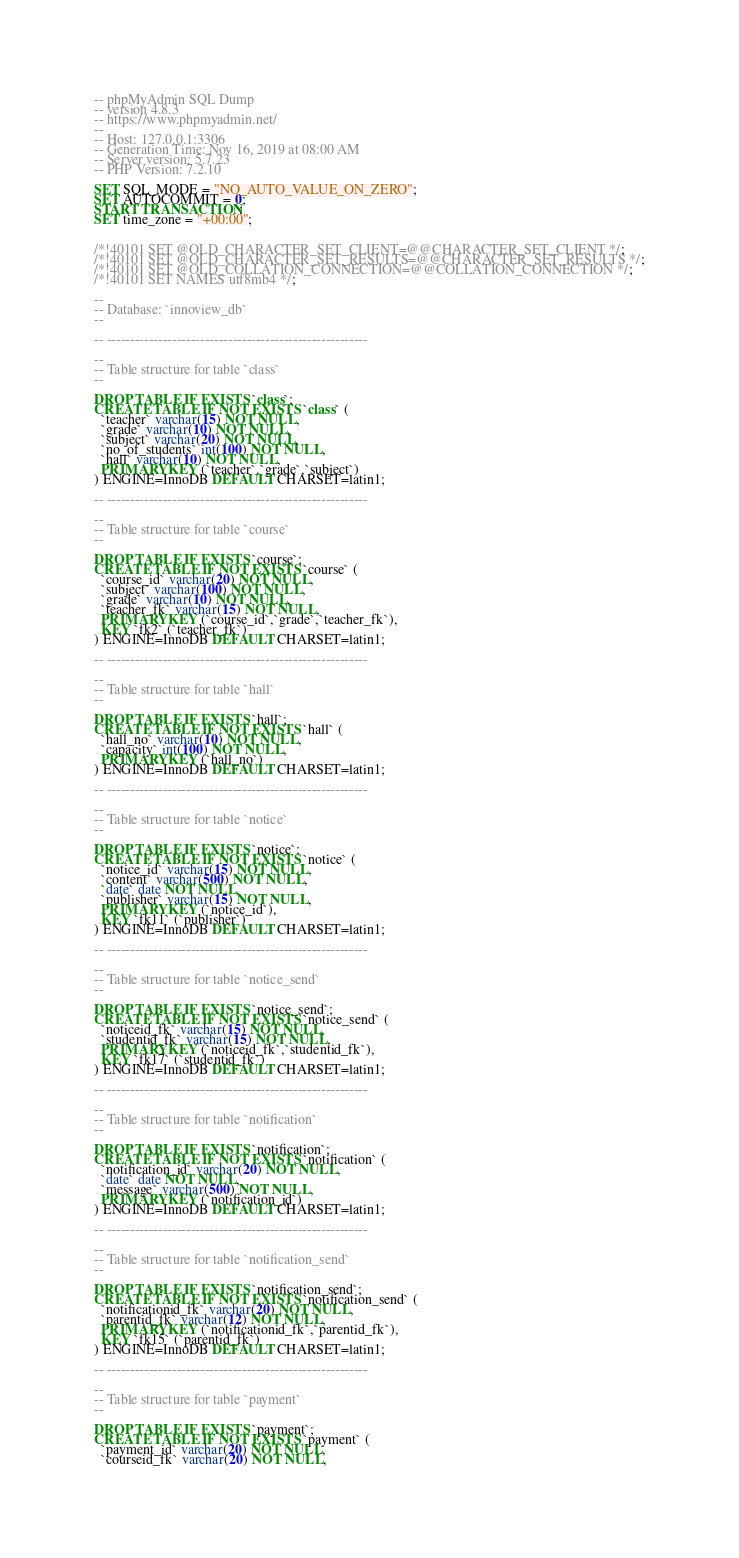<code> <loc_0><loc_0><loc_500><loc_500><_SQL_>-- phpMyAdmin SQL Dump
-- version 4.8.3
-- https://www.phpmyadmin.net/
--
-- Host: 127.0.0.1:3306
-- Generation Time: Nov 16, 2019 at 08:00 AM
-- Server version: 5.7.23
-- PHP Version: 7.2.10

SET SQL_MODE = "NO_AUTO_VALUE_ON_ZERO";
SET AUTOCOMMIT = 0;
START TRANSACTION;
SET time_zone = "+00:00";


/*!40101 SET @OLD_CHARACTER_SET_CLIENT=@@CHARACTER_SET_CLIENT */;
/*!40101 SET @OLD_CHARACTER_SET_RESULTS=@@CHARACTER_SET_RESULTS */;
/*!40101 SET @OLD_COLLATION_CONNECTION=@@COLLATION_CONNECTION */;
/*!40101 SET NAMES utf8mb4 */;

--
-- Database: `innoview_db`
--

-- --------------------------------------------------------

--
-- Table structure for table `class`
--

DROP TABLE IF EXISTS `class`;
CREATE TABLE IF NOT EXISTS `class` (
  `teacher` varchar(15) NOT NULL,
  `grade` varchar(10) NOT NULL,
  `subject` varchar(20) NOT NULL,
  `no_of_students` int(100) NOT NULL,
  `hall` varchar(10) NOT NULL,
  PRIMARY KEY (`teacher`,`grade`,`subject`)
) ENGINE=InnoDB DEFAULT CHARSET=latin1;

-- --------------------------------------------------------

--
-- Table structure for table `course`
--

DROP TABLE IF EXISTS `course`;
CREATE TABLE IF NOT EXISTS `course` (
  `course_id` varchar(20) NOT NULL,
  `subject` varchar(100) NOT NULL,
  `grade` varchar(10) NOT NULL,
  `teacher_fk` varchar(15) NOT NULL,
  PRIMARY KEY (`course_id`,`grade`,`teacher_fk`),
  KEY `fk2` (`teacher_fk`)
) ENGINE=InnoDB DEFAULT CHARSET=latin1;

-- --------------------------------------------------------

--
-- Table structure for table `hall`
--

DROP TABLE IF EXISTS `hall`;
CREATE TABLE IF NOT EXISTS `hall` (
  `hall_no` varchar(10) NOT NULL,
  `capacity` int(100) NOT NULL,
  PRIMARY KEY (`hall_no`)
) ENGINE=InnoDB DEFAULT CHARSET=latin1;

-- --------------------------------------------------------

--
-- Table structure for table `notice`
--

DROP TABLE IF EXISTS `notice`;
CREATE TABLE IF NOT EXISTS `notice` (
  `notice_id` varchar(15) NOT NULL,
  `content` varchar(500) NOT NULL,
  `date` date NOT NULL,
  `publisher` varchar(15) NOT NULL,
  PRIMARY KEY (`notice_id`),
  KEY `fk11` (`publisher`)
) ENGINE=InnoDB DEFAULT CHARSET=latin1;

-- --------------------------------------------------------

--
-- Table structure for table `notice_send`
--

DROP TABLE IF EXISTS `notice_send`;
CREATE TABLE IF NOT EXISTS `notice_send` (
  `noticeid_fk` varchar(15) NOT NULL,
  `studentid_fk` varchar(15) NOT NULL,
  PRIMARY KEY (`noticeid_fk`,`studentid_fk`),
  KEY `fk17` (`studentid_fk`)
) ENGINE=InnoDB DEFAULT CHARSET=latin1;

-- --------------------------------------------------------

--
-- Table structure for table `notification`
--

DROP TABLE IF EXISTS `notification`;
CREATE TABLE IF NOT EXISTS `notification` (
  `notification_id` varchar(20) NOT NULL,
  `date` date NOT NULL,
  `message` varchar(500) NOT NULL,
  PRIMARY KEY (`notification_id`)
) ENGINE=InnoDB DEFAULT CHARSET=latin1;

-- --------------------------------------------------------

--
-- Table structure for table `notification_send`
--

DROP TABLE IF EXISTS `notification_send`;
CREATE TABLE IF NOT EXISTS `notification_send` (
  `notificationid_fk` varchar(20) NOT NULL,
  `parentid_fk` varchar(12) NOT NULL,
  PRIMARY KEY (`notificationid_fk`,`parentid_fk`),
  KEY `fk15` (`parentid_fk`)
) ENGINE=InnoDB DEFAULT CHARSET=latin1;

-- --------------------------------------------------------

--
-- Table structure for table `payment`
--

DROP TABLE IF EXISTS `payment`;
CREATE TABLE IF NOT EXISTS `payment` (
  `payment_id` varchar(20) NOT NULL,
  `courseid_fk` varchar(20) NOT NULL,</code> 